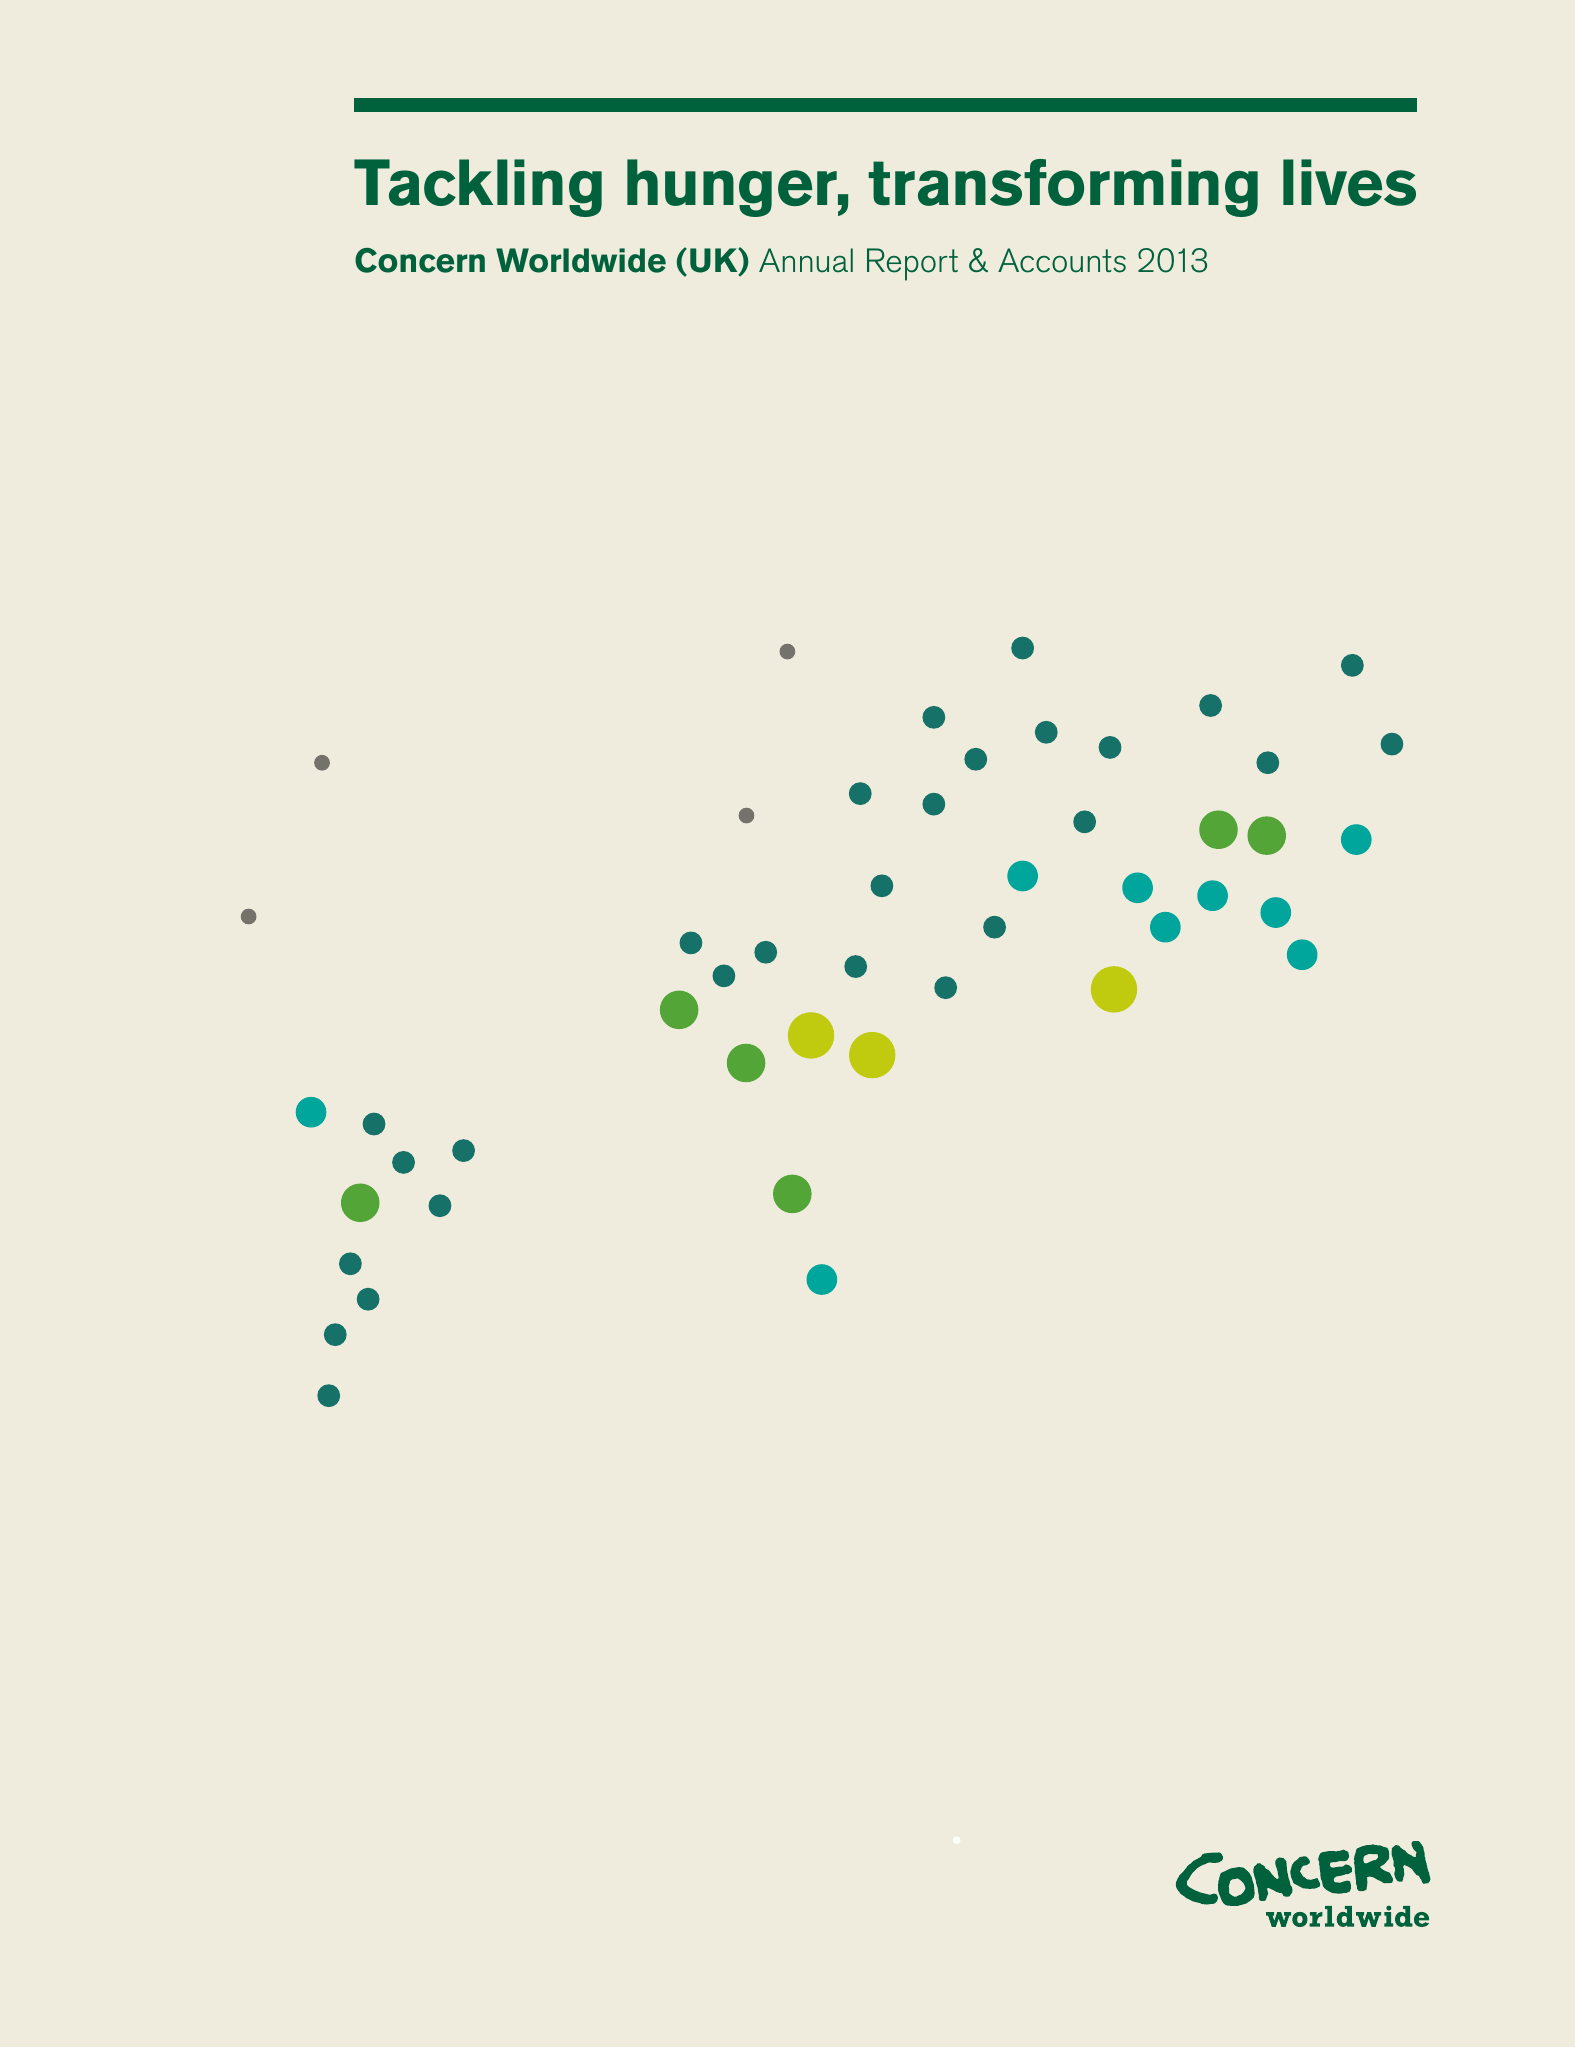What is the value for the charity_number?
Answer the question using a single word or phrase. 1092236 